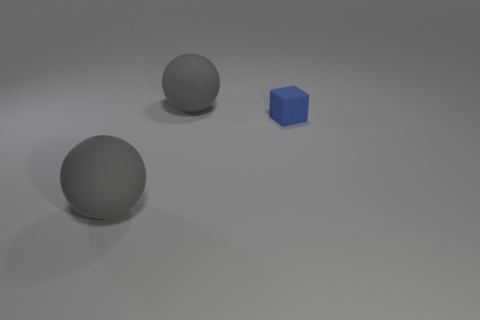Are the small blue cube and the large gray sphere that is in front of the tiny blue matte thing made of the same material?
Your answer should be very brief. Yes. The matte thing in front of the tiny matte cube is what color?
Your answer should be compact. Gray. Does the rubber object in front of the blue matte cube have the same size as the tiny cube?
Provide a short and direct response. No. There is a tiny blue block; how many gray rubber objects are behind it?
Keep it short and to the point. 1. Is there another rubber cube of the same size as the blue cube?
Give a very brief answer. No. What is the color of the object that is to the left of the large thing behind the blue cube?
Make the answer very short. Gray. How many big gray objects are the same shape as the small blue thing?
Provide a short and direct response. 0. What shape is the tiny thing that is right of the matte sphere in front of the blue cube?
Make the answer very short. Cube. What number of balls are to the left of the large gray sphere that is behind the tiny blue block?
Provide a short and direct response. 1. There is a rubber cube to the right of the matte thing on the left side of the big sphere that is behind the tiny rubber object; what is its color?
Keep it short and to the point. Blue. 